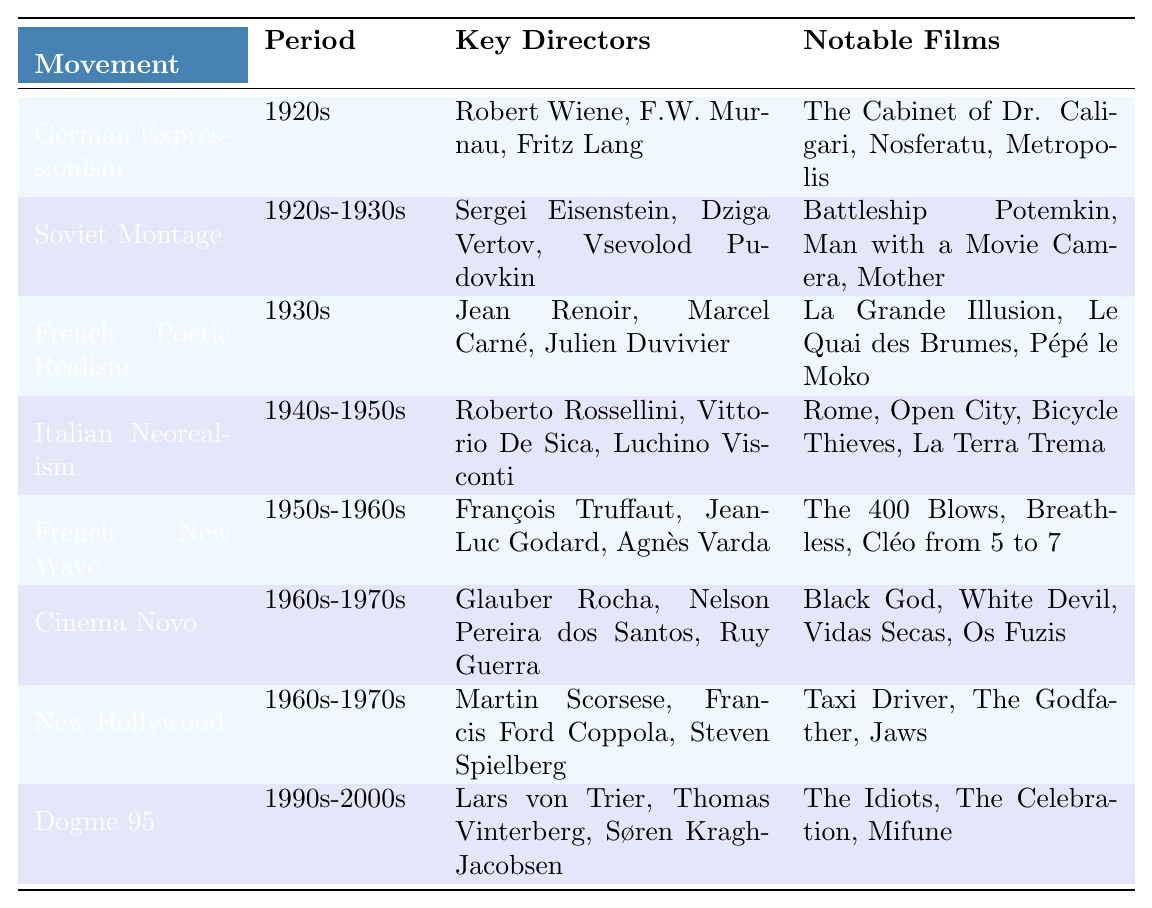What are the key directors associated with French New Wave? The table lists "François Truffaut, Jean-Luc Godard, Agnès Varda" as the key directors for the French New Wave movement.
Answer: François Truffaut, Jean-Luc Godard, Agnès Varda Which film is notable from German Expressionism? According to the table, notable films from German Expressionism include "The Cabinet of Dr. Caligari, Nosferatu, Metropolis." One example is "The Cabinet of Dr. Caligari."
Answer: The Cabinet of Dr. Caligari How many film movements were active during the 1960s-1970s? The table shows two movements: "Cinema Novo" and "New Hollywood," that were active in the 1960s-1970s.
Answer: 2 Is Roberto Rossellini a key director of Italian Neorealism? The table lists Roberto Rossellini as one of the key directors for Italian Neorealism, which confirms that the statement is true.
Answer: Yes Which film from the 1940s-1950s movement is a notable work? The table indicates that notable films for Italian Neorealism include "Rome, Open City, Bicycle Thieves, La Terra Trema." A notable work is "Bicycle Thieves."
Answer: Bicycle Thieves Which film movements feature directors who have the first name "Martin"? Among the film movements listed, "New Hollywood" features Martin Scorsese as a key director. Therefore, it is the only movement that fits the criteria.
Answer: New Hollywood Which movement had the most notable films listed? Counting the notable films from each movement in the table, all movements have three notable films listed. Therefore, they have equal counts.
Answer: Equal counts Compare the key directors of Soviet Montage and German Expressionism. The table shows "Soviet Montage" key directors as "Sergei Eisenstein, Dziga Vertov, Vsevolod Pudovkin" and "German Expressionism" key directors as "Robert Wiene, F.W. Murnau, Fritz Lang." Both lists contain three directors each.
Answer: Equal numbers of key directors What is the relationship between the Dogme 95 movement and the 1990s-2000s period? According to the table, Dogme 95 is categorized within the 1990s-2000s period. Therefore, the relationship is direct as it aligns with that timeline.
Answer: Direct relationship Which key director is shared among the movements of French New Wave and Cinema Novo? The table shows that there are no shared key directors between these two movements. Therefore, the answer is none.
Answer: None Which movement has the earliest recorded period and what is it? The table indicates that "German Expressionism," active in the 1920s, has the earliest recorded period compared to other movements.
Answer: German Expressionism, 1920s 